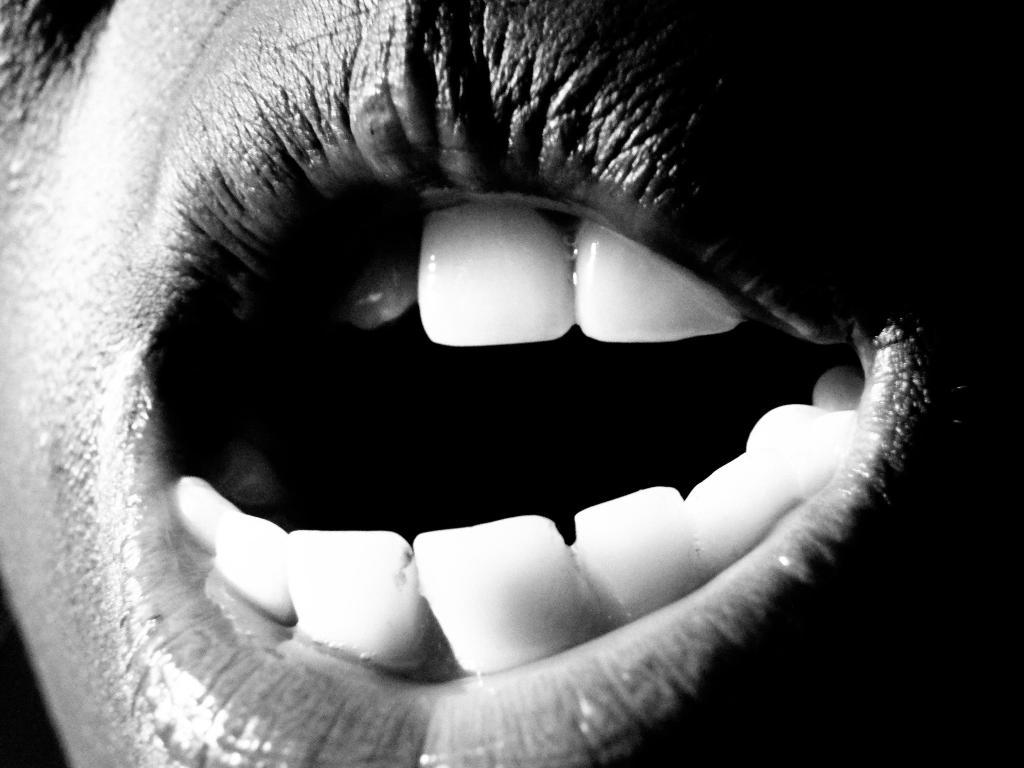What part of the person's body is visible in the image? The image contains a person's mouth. What can be seen inside the person's mouth in the image? The person's teeth are visible in the image. What type of cracker is floating on the lake in the image? There is no lake or cracker present in the image; it only features a person's mouth and teeth. 